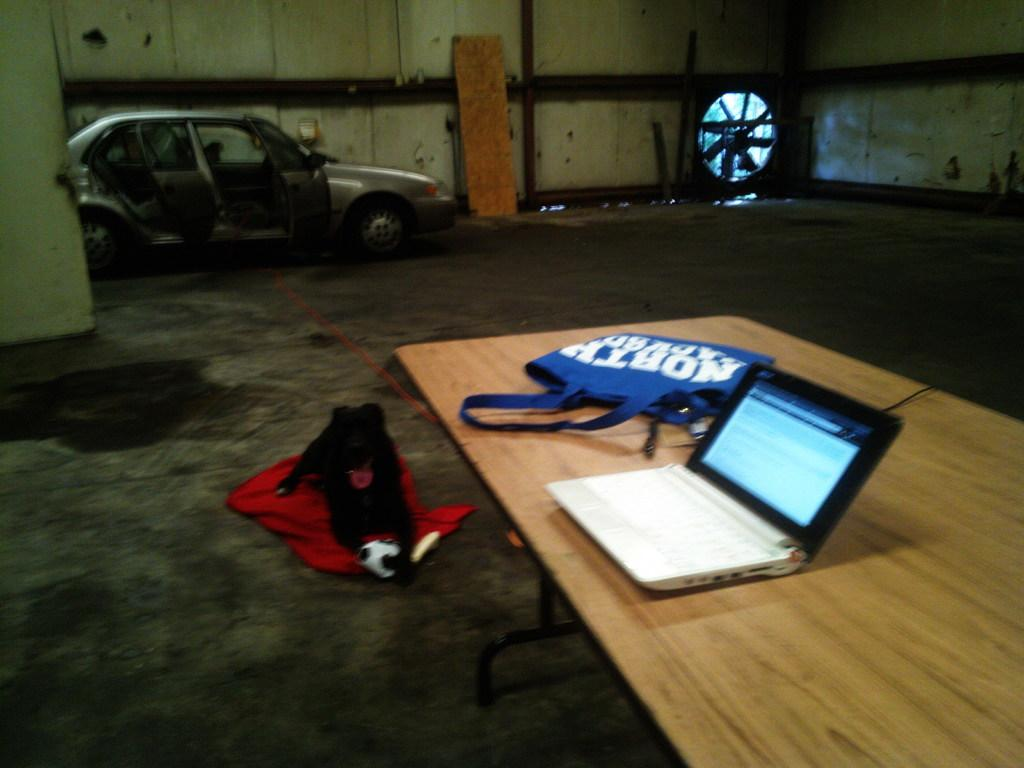What type of vehicle is in the image? There is a car in the image. What furniture is present in the image? There is a table in the image. What electronic device is on the table? There is a laptop on the table. What type of bag is on the table? There is a blue color bag on the table. What animal is on the floor in the image? There is a black color dog on the floor. Where is the playground located in the image? There is no playground present in the image. What type of needle is used by the dog in the image? There are no needles or any indication of sewing in the image. 